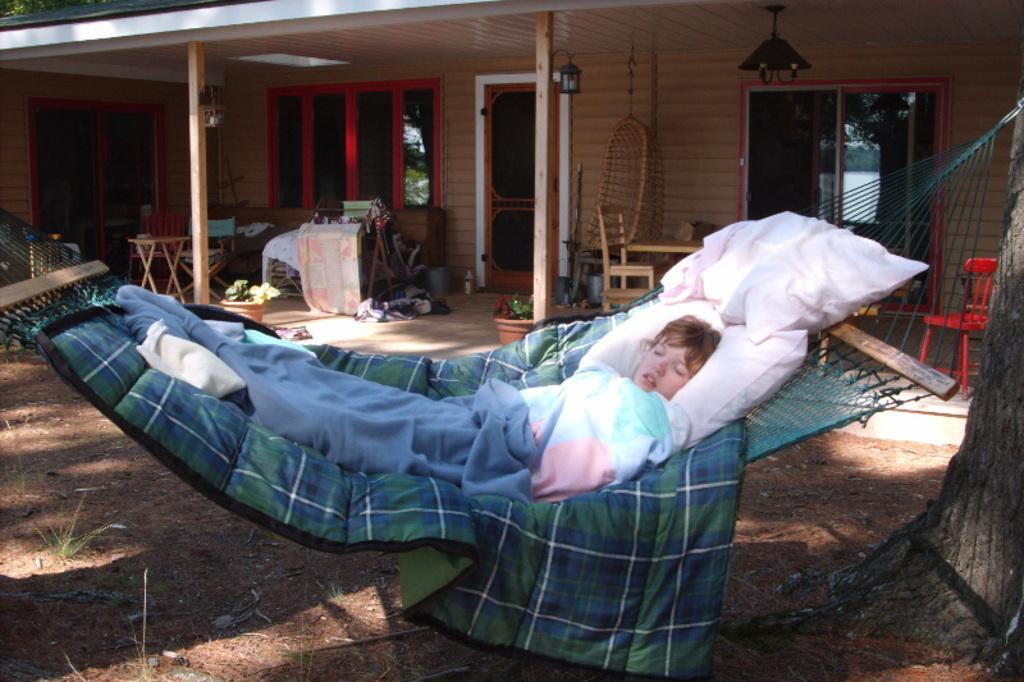Can you describe this image briefly? In this image I see a child who is lying on this thing and I see the ground and I see the tree over here. In the background I see the chairs and I see a table over here and I see the windows and I see the light over here and I see the door. 